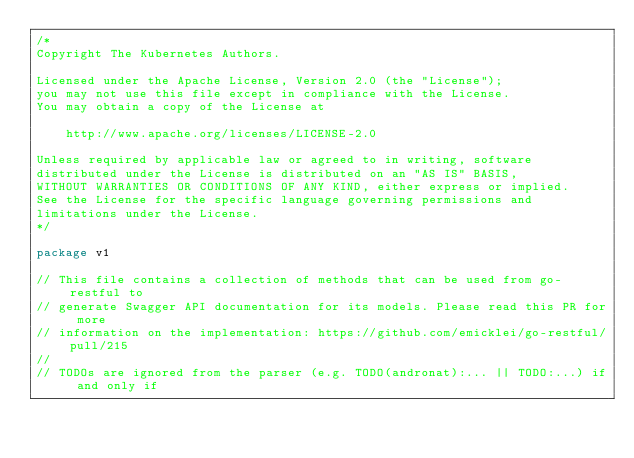<code> <loc_0><loc_0><loc_500><loc_500><_Go_>/*
Copyright The Kubernetes Authors.

Licensed under the Apache License, Version 2.0 (the "License");
you may not use this file except in compliance with the License.
You may obtain a copy of the License at

    http://www.apache.org/licenses/LICENSE-2.0

Unless required by applicable law or agreed to in writing, software
distributed under the License is distributed on an "AS IS" BASIS,
WITHOUT WARRANTIES OR CONDITIONS OF ANY KIND, either express or implied.
See the License for the specific language governing permissions and
limitations under the License.
*/

package v1

// This file contains a collection of methods that can be used from go-restful to
// generate Swagger API documentation for its models. Please read this PR for more
// information on the implementation: https://github.com/emicklei/go-restful/pull/215
//
// TODOs are ignored from the parser (e.g. TODO(andronat):... || TODO:...) if and only if</code> 